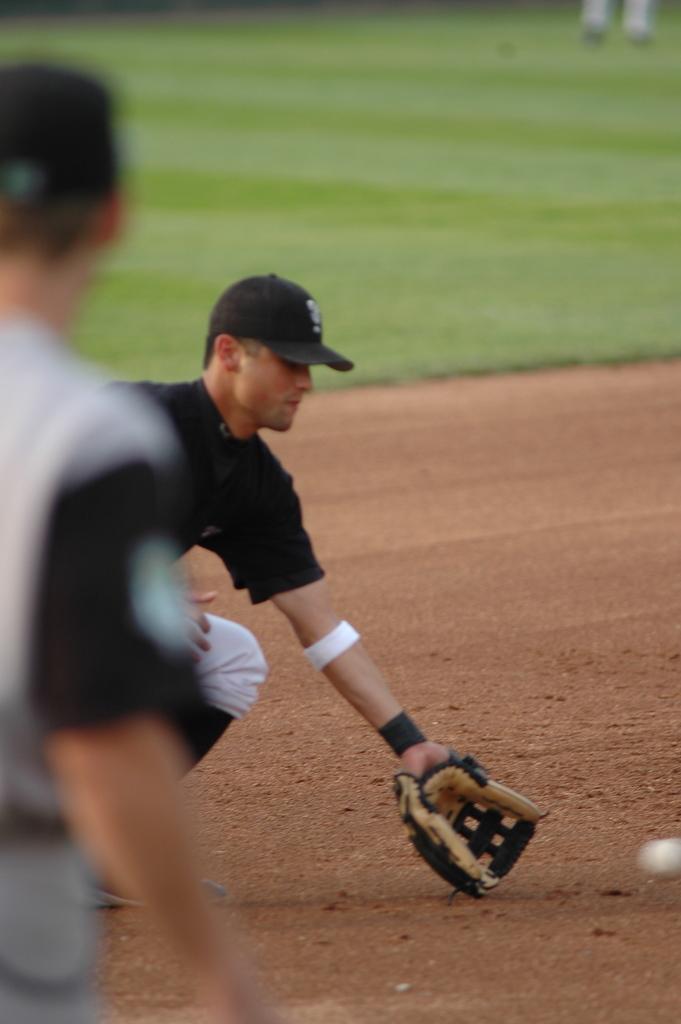Can you describe this image briefly? In this image I can see two persons visible on left side and I can see a man holding a glove and I can see a ball on the right side at the top I can see grass. 